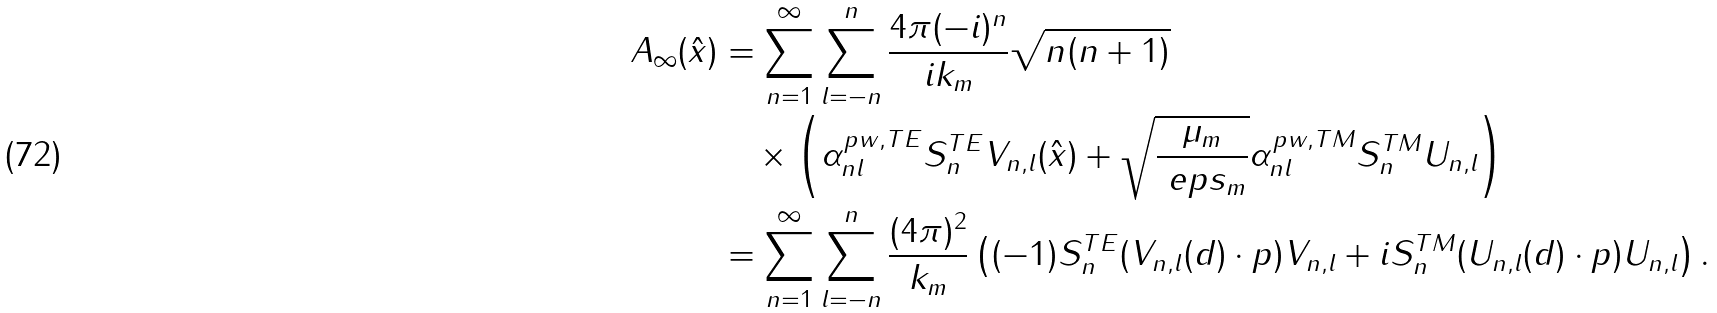Convert formula to latex. <formula><loc_0><loc_0><loc_500><loc_500>A _ { \infty } ( \hat { x } ) & = \sum _ { n = 1 } ^ { \infty } \sum _ { l = - n } ^ { n } \frac { 4 \pi ( - i ) ^ { n } } { i k _ { m } } \sqrt { n ( n + 1 ) } \\ & \quad \times \left ( \alpha ^ { p w , T E } _ { n l } S ^ { T E } _ { n } V _ { n , l } ( \hat { x } ) + \sqrt { \frac { \mu _ { m } } { \ e p s _ { m } } } \alpha ^ { p w , T M } _ { n l } S ^ { T M } _ { n } U _ { n , l } \right ) \\ & = \sum _ { n = 1 } ^ { \infty } \sum _ { l = - n } ^ { n } \frac { ( 4 \pi ) ^ { 2 } } { k _ { m } } \left ( ( - 1 ) S _ { n } ^ { T E } ( V _ { n , l } ( d ) \cdot p ) V _ { n , l } + i S _ { n } ^ { T M } ( U _ { n , l } ( d ) \cdot p ) U _ { n , l } \right ) .</formula> 